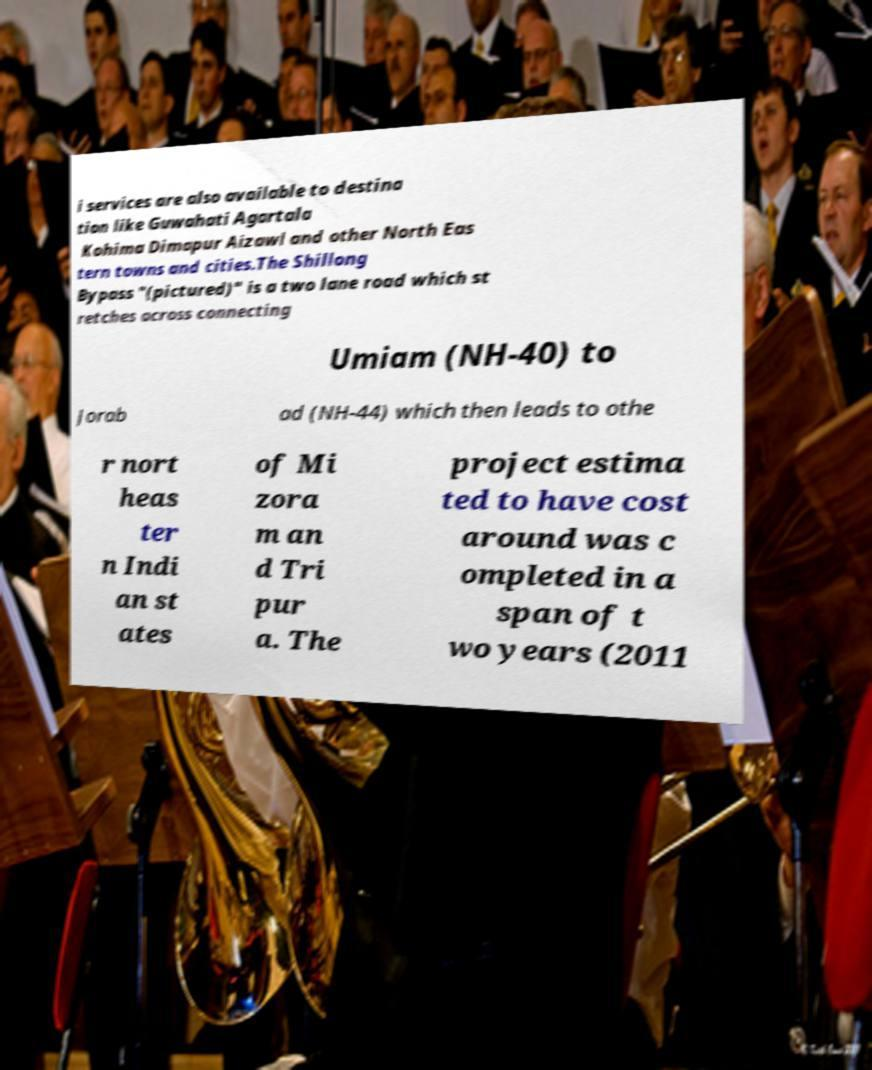Can you accurately transcribe the text from the provided image for me? i services are also available to destina tion like Guwahati Agartala Kohima Dimapur Aizawl and other North Eas tern towns and cities.The Shillong Bypass "(pictured)" is a two lane road which st retches across connecting Umiam (NH-40) to Jorab ad (NH-44) which then leads to othe r nort heas ter n Indi an st ates of Mi zora m an d Tri pur a. The project estima ted to have cost around was c ompleted in a span of t wo years (2011 